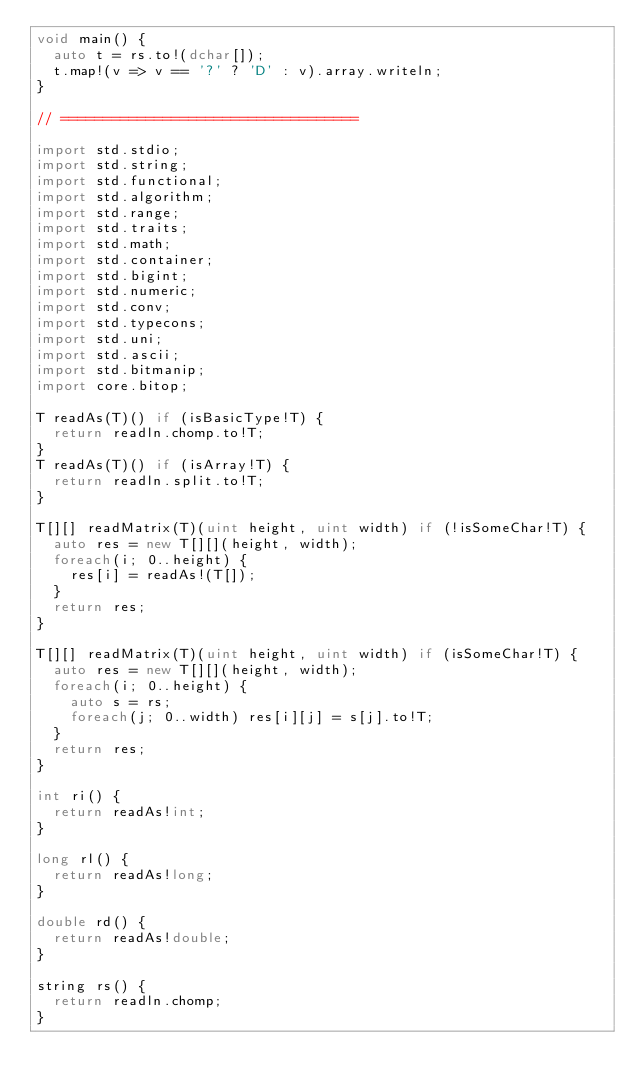<code> <loc_0><loc_0><loc_500><loc_500><_D_>void main() {
	auto t = rs.to!(dchar[]);
	t.map!(v => v == '?' ? 'D' : v).array.writeln;
}

// ===================================

import std.stdio;
import std.string;
import std.functional;
import std.algorithm;
import std.range;
import std.traits;
import std.math;
import std.container;
import std.bigint;
import std.numeric;
import std.conv;
import std.typecons;
import std.uni;
import std.ascii;
import std.bitmanip;
import core.bitop;

T readAs(T)() if (isBasicType!T) {
	return readln.chomp.to!T;
}
T readAs(T)() if (isArray!T) {
	return readln.split.to!T;
}

T[][] readMatrix(T)(uint height, uint width) if (!isSomeChar!T) {
	auto res = new T[][](height, width);
	foreach(i; 0..height) {
		res[i] = readAs!(T[]);
	}
	return res;
}

T[][] readMatrix(T)(uint height, uint width) if (isSomeChar!T) {
	auto res = new T[][](height, width);
	foreach(i; 0..height) {
		auto s = rs;
		foreach(j; 0..width) res[i][j] = s[j].to!T;
	}
	return res;
}

int ri() {
	return readAs!int;
}

long rl() {
	return readAs!long;
}

double rd() {
	return readAs!double;
}

string rs() {
	return readln.chomp;
}</code> 